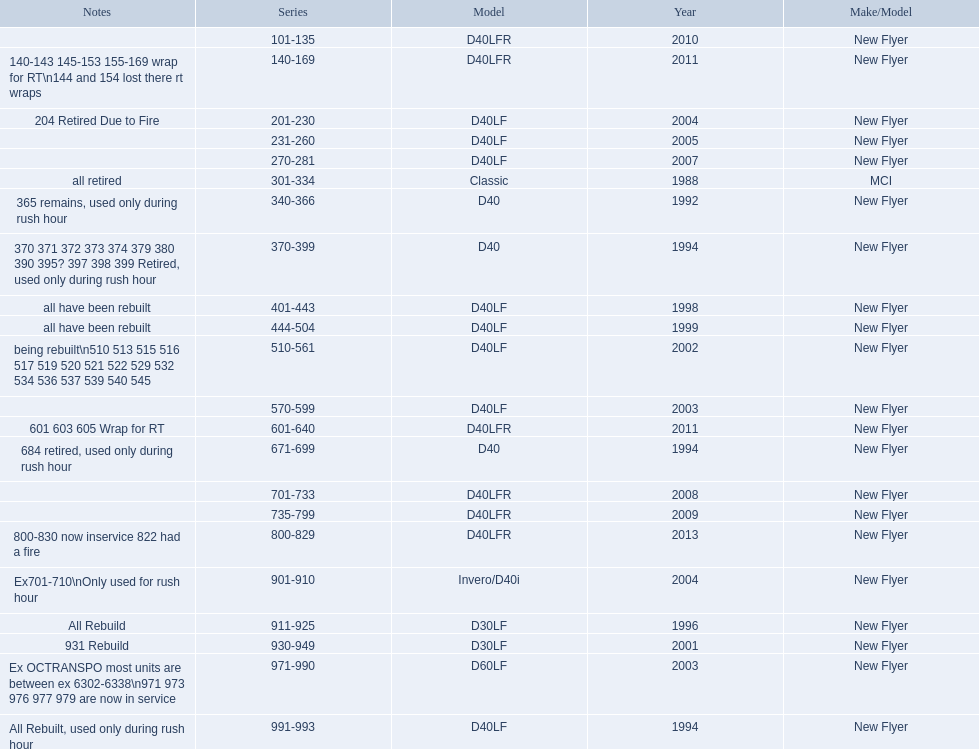Give me the full table as a dictionary. {'header': ['Notes', 'Series', 'Model', 'Year', 'Make/Model'], 'rows': [['', '101-135', 'D40LFR', '2010', 'New Flyer'], ['140-143 145-153 155-169 wrap for RT\\n144 and 154 lost there rt wraps', '140-169', 'D40LFR', '2011', 'New Flyer'], ['204 Retired Due to Fire', '201-230', 'D40LF', '2004', 'New Flyer'], ['', '231-260', 'D40LF', '2005', 'New Flyer'], ['', '270-281', 'D40LF', '2007', 'New Flyer'], ['all retired', '301-334', 'Classic', '1988', 'MCI'], ['365 remains, used only during rush hour', '340-366', 'D40', '1992', 'New Flyer'], ['370 371 372 373 374 379 380 390 395? 397 398 399 Retired, used only during rush hour', '370-399', 'D40', '1994', 'New Flyer'], ['all have been rebuilt', '401-443', 'D40LF', '1998', 'New Flyer'], ['all have been rebuilt', '444-504', 'D40LF', '1999', 'New Flyer'], ['being rebuilt\\n510 513 515 516 517 519 520 521 522 529 532 534 536 537 539 540 545', '510-561', 'D40LF', '2002', 'New Flyer'], ['', '570-599', 'D40LF', '2003', 'New Flyer'], ['601 603 605 Wrap for RT', '601-640', 'D40LFR', '2011', 'New Flyer'], ['684 retired, used only during rush hour', '671-699', 'D40', '1994', 'New Flyer'], ['', '701-733', 'D40LFR', '2008', 'New Flyer'], ['', '735-799', 'D40LFR', '2009', 'New Flyer'], ['800-830 now inservice 822 had a fire', '800-829', 'D40LFR', '2013', 'New Flyer'], ['Ex701-710\\nOnly used for rush hour', '901-910', 'Invero/D40i', '2004', 'New Flyer'], ['All Rebuild', '911-925', 'D30LF', '1996', 'New Flyer'], ['931 Rebuild', '930-949', 'D30LF', '2001', 'New Flyer'], ['Ex OCTRANSPO most units are between ex 6302-6338\\n971 973 976 977 979 are now in service', '971-990', 'D60LF', '2003', 'New Flyer'], ['All Rebuilt, used only during rush hour', '991-993', 'D40LF', '1994', 'New Flyer']]} What are all of the bus series numbers? 101-135, 140-169, 201-230, 231-260, 270-281, 301-334, 340-366, 370-399, 401-443, 444-504, 510-561, 570-599, 601-640, 671-699, 701-733, 735-799, 800-829, 901-910, 911-925, 930-949, 971-990, 991-993. When were they introduced? 2010, 2011, 2004, 2005, 2007, 1988, 1992, 1994, 1998, 1999, 2002, 2003, 2011, 1994, 2008, 2009, 2013, 2004, 1996, 2001, 2003, 1994. Which series is the newest? 800-829. 